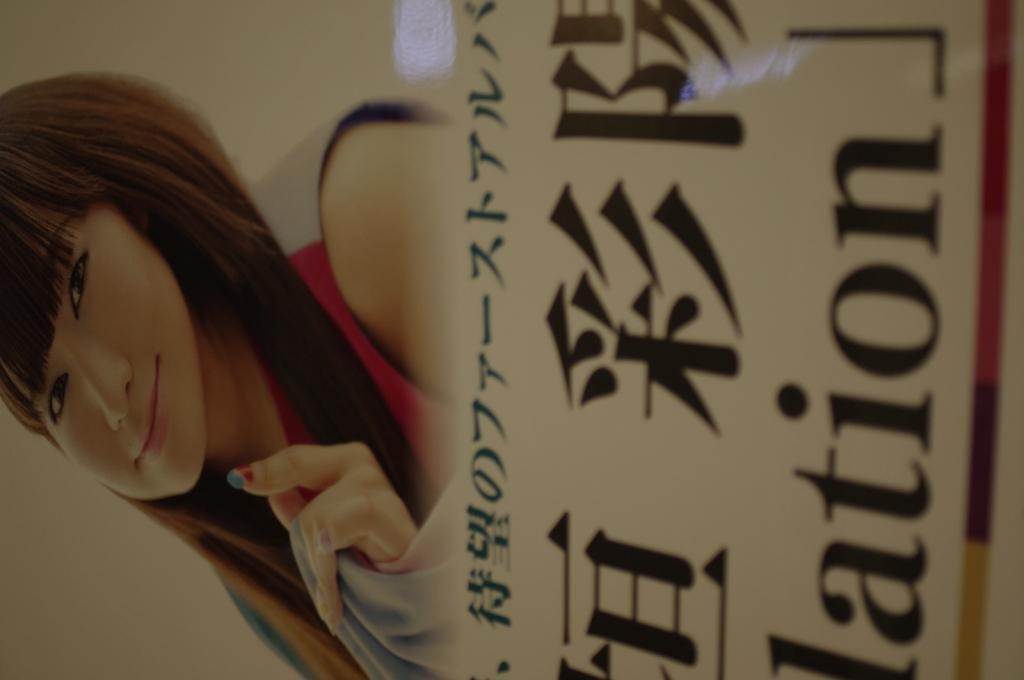What is the main subject of the poster in the image? The poster contains a picture of a woman. What else can be found on the poster besides the image? There is text on the poster. How many teeth can be seen on the sheep in the image? There is no sheep present in the image, and therefore no teeth can be observed. 